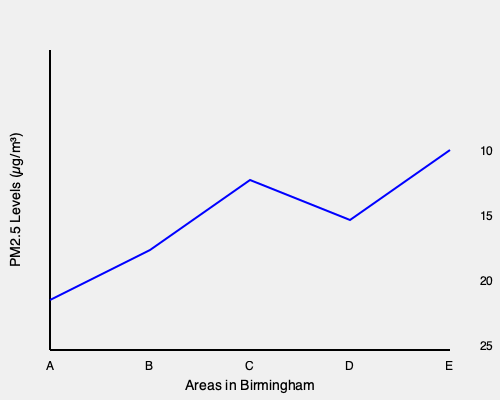Based on the graph showing PM2.5 levels in different areas of Birmingham, which area would likely have the most significant negative impact on a runner's performance, and why? To determine which area would have the most significant negative impact on a runner's performance, we need to analyze the PM2.5 levels shown in the graph for different areas of Birmingham. PM2.5 refers to fine particulate matter that can be inhaled and affect lung function. Higher levels of PM2.5 are generally associated with poorer air quality and can negatively impact running performance.

Let's examine the PM2.5 levels for each area:

1. Area A: Approximately 25 µg/m³
2. Area B: Approximately 22 µg/m³
3. Area C: Approximately 18 µg/m³
4. Area D: Approximately 20 µg/m³
5. Area E: Approximately 10 µg/m³

The World Health Organization (WHO) guideline for annual mean PM2.5 is 10 µg/m³. Higher levels can lead to various health effects, including reduced lung function and increased respiratory symptoms.

For runners, higher PM2.5 levels can:
1. Reduce oxygen uptake efficiency
2. Increase breathing rate and heart rate
3. Cause inflammation in the respiratory system
4. Lead to fatigue and decreased endurance

Among the areas shown, Area A has the highest PM2.5 level at approximately 25 µg/m³, which is 2.5 times the WHO guideline. This area would likely have the most significant negative impact on a runner's performance due to the following reasons:

1. Highest pollution level: Area A has the poorest air quality among all areas shown.
2. Greatest potential for respiratory stress: The high PM2.5 level in Area A is most likely to cause respiratory irritation and reduced lung function.
3. Increased cardiovascular strain: Running in Area A would likely lead to a higher heart rate and greater perceived exertion compared to other areas.
4. Potential for long-term health effects: Regular exposure to high PM2.5 levels can lead to chronic health issues, which could impact overall running performance over time.

Therefore, Area A would likely have the most significant negative impact on a runner's performance due to its highest PM2.5 level among the areas shown.
Answer: Area A, due to highest PM2.5 level (25 µg/m³). 